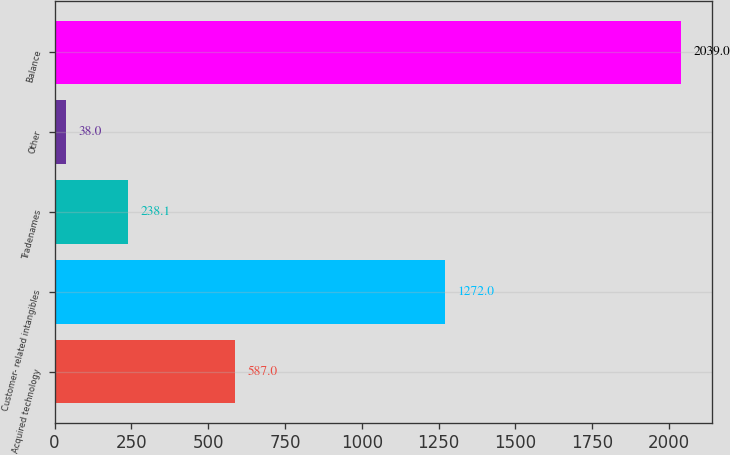<chart> <loc_0><loc_0><loc_500><loc_500><bar_chart><fcel>Acquired technology<fcel>Customer- related intangibles<fcel>Tradenames<fcel>Other<fcel>Balance<nl><fcel>587<fcel>1272<fcel>238.1<fcel>38<fcel>2039<nl></chart> 